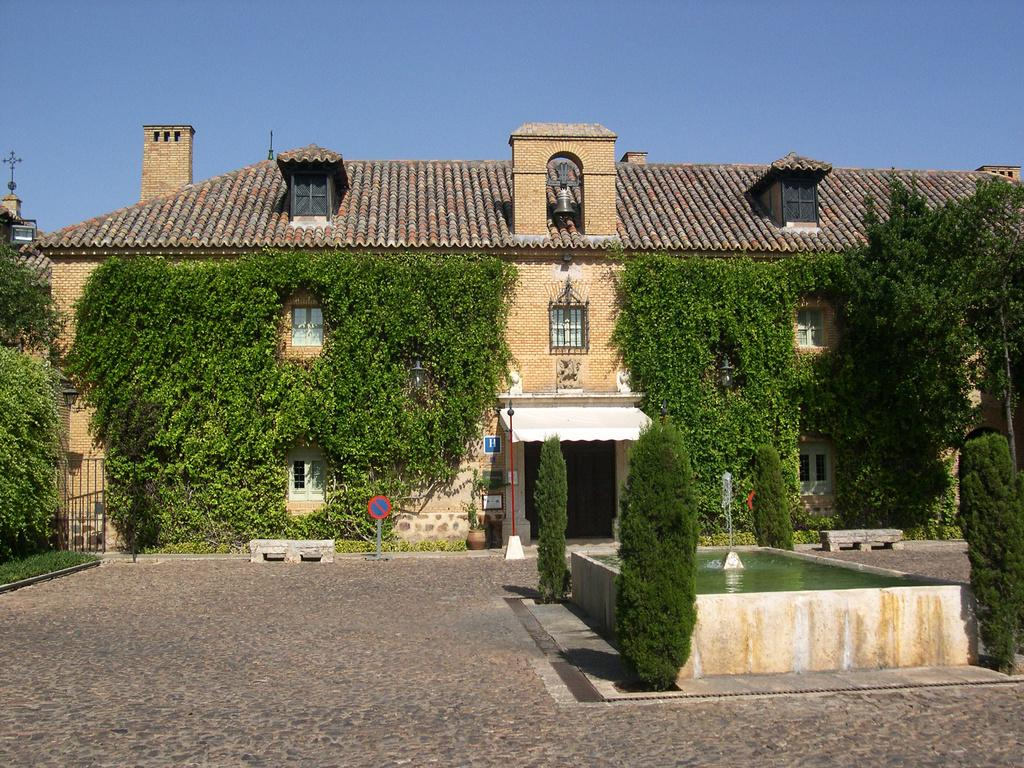What type of structure can be seen in the image? There is a building in the image. What type of vegetation is present in the image? Creepers are present in the image. What type of cooking equipment is visible in the image? Grills are visible in the image. What type of support structures are in the image? Poles are in the image. What type of water feature is present in the image? There is a fountain in the image. What type of seating is available in the image? Benches are present in the image. How does the ice affect the pet's behavior in the image? There is no ice or pet present in the image. 